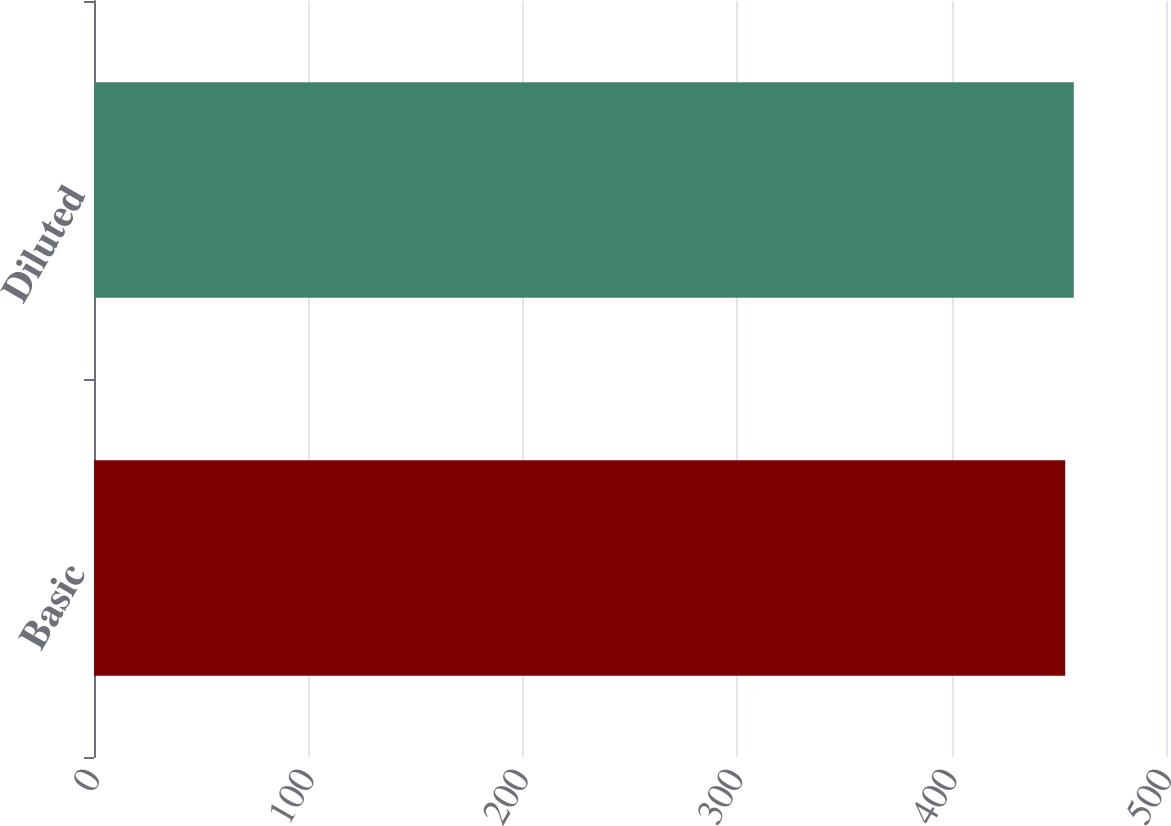Convert chart to OTSL. <chart><loc_0><loc_0><loc_500><loc_500><bar_chart><fcel>Basic<fcel>Diluted<nl><fcel>453<fcel>457<nl></chart> 